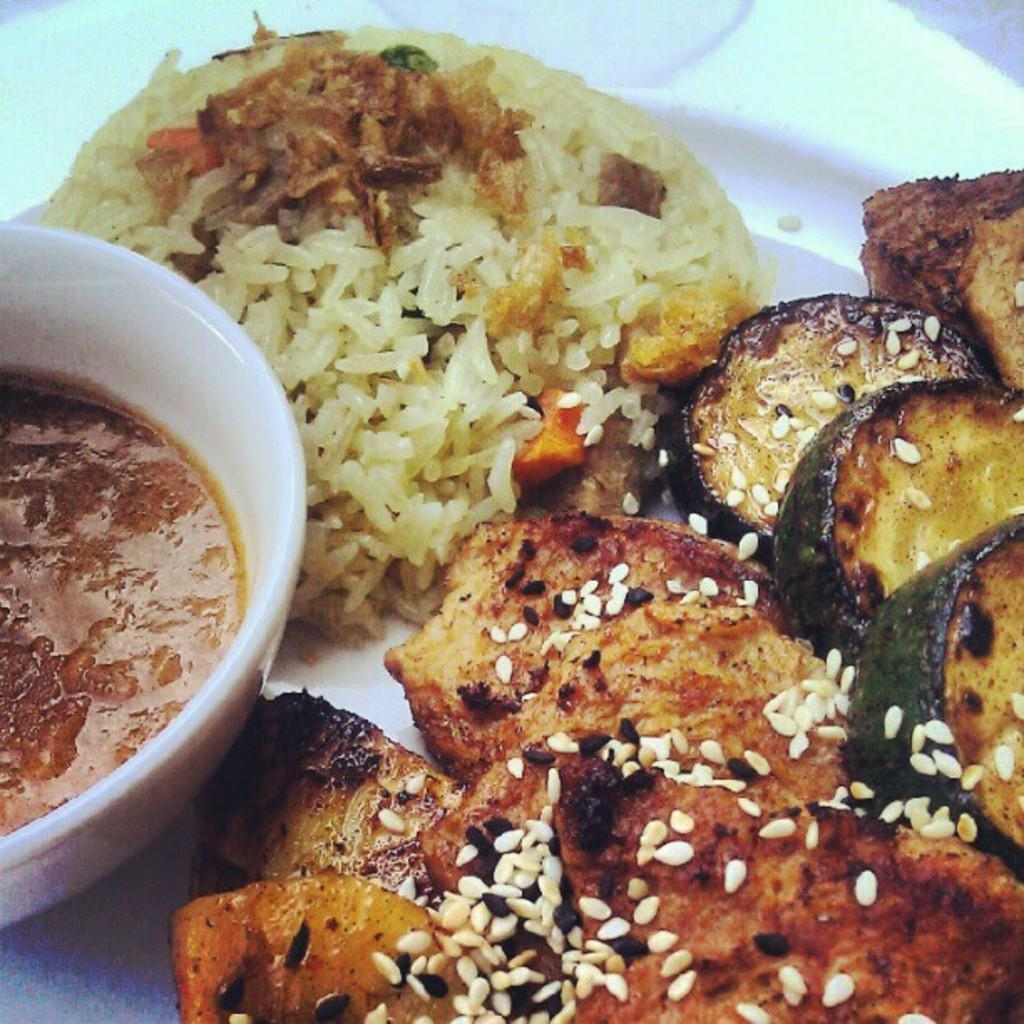What is present in the image that people typically consume? There is food in the image. What type of container is holding the food? There is a bowl in the image. Is the bowl placed on another surface? Yes, the bowl is on a plate. What type of protest is happening in the image? There is no protest present in the image. 